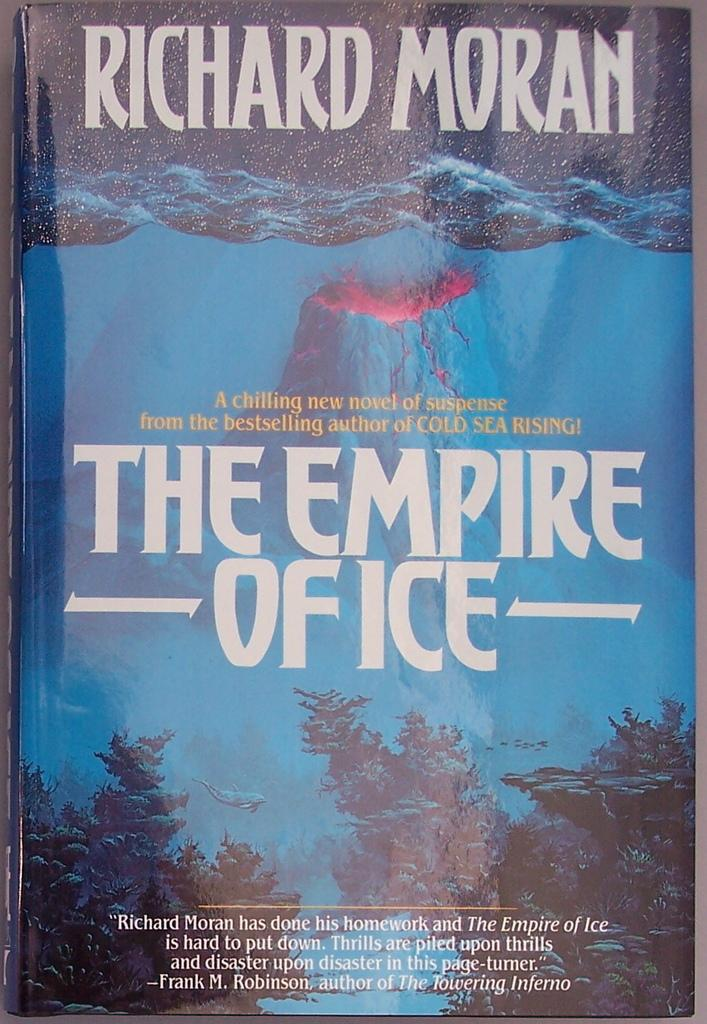<image>
Describe the image concisely. A book by Richard Moran has trees on the front of it. 